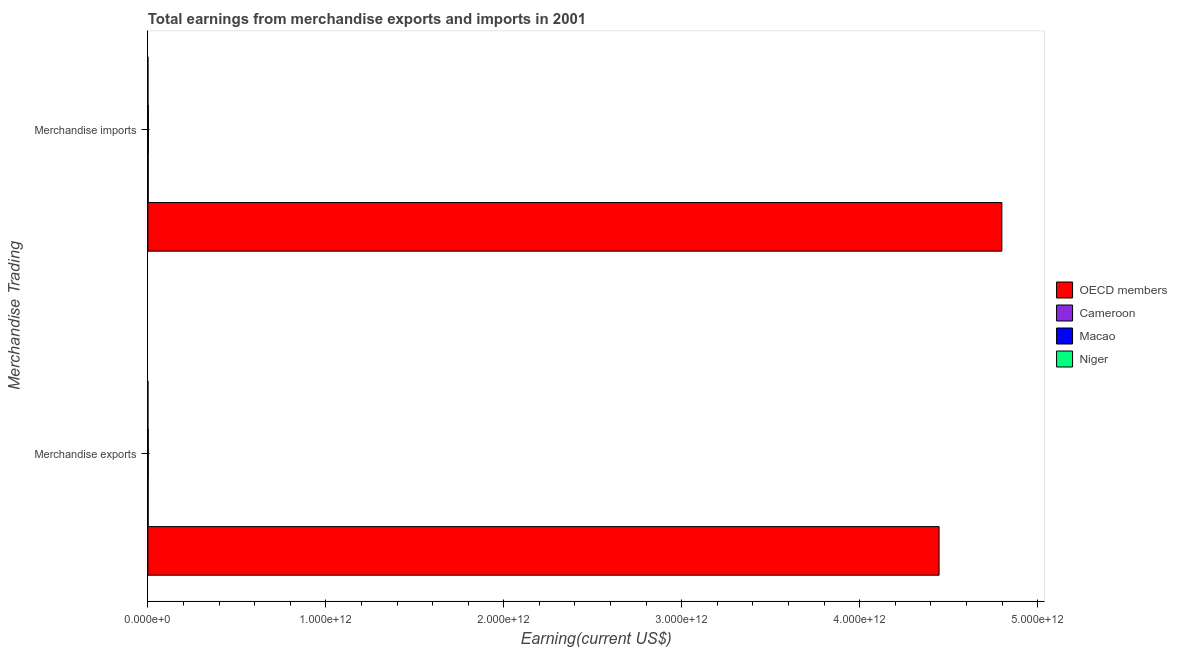How many different coloured bars are there?
Provide a short and direct response. 4. Are the number of bars per tick equal to the number of legend labels?
Ensure brevity in your answer.  Yes. What is the earnings from merchandise exports in Macao?
Ensure brevity in your answer.  2.30e+09. Across all countries, what is the maximum earnings from merchandise exports?
Provide a succinct answer. 4.45e+12. Across all countries, what is the minimum earnings from merchandise exports?
Offer a terse response. 2.72e+08. In which country was the earnings from merchandise exports maximum?
Ensure brevity in your answer.  OECD members. In which country was the earnings from merchandise exports minimum?
Give a very brief answer. Niger. What is the total earnings from merchandise exports in the graph?
Provide a succinct answer. 4.45e+12. What is the difference between the earnings from merchandise imports in Macao and that in Niger?
Your response must be concise. 2.41e+09. What is the difference between the earnings from merchandise imports in Macao and the earnings from merchandise exports in Cameroon?
Your answer should be compact. 1.07e+09. What is the average earnings from merchandise exports per country?
Keep it short and to the point. 1.11e+12. What is the difference between the earnings from merchandise exports and earnings from merchandise imports in Cameroon?
Provide a succinct answer. -1.03e+08. What is the ratio of the earnings from merchandise imports in OECD members to that in Niger?
Keep it short and to the point. 1.16e+04. Is the earnings from merchandise imports in OECD members less than that in Macao?
Your answer should be compact. No. In how many countries, is the earnings from merchandise imports greater than the average earnings from merchandise imports taken over all countries?
Provide a short and direct response. 1. What does the 3rd bar from the bottom in Merchandise exports represents?
Your answer should be very brief. Macao. How many countries are there in the graph?
Your answer should be compact. 4. What is the difference between two consecutive major ticks on the X-axis?
Give a very brief answer. 1.00e+12. Where does the legend appear in the graph?
Offer a very short reply. Center right. How are the legend labels stacked?
Your answer should be compact. Vertical. What is the title of the graph?
Provide a succinct answer. Total earnings from merchandise exports and imports in 2001. Does "Low & middle income" appear as one of the legend labels in the graph?
Your answer should be very brief. No. What is the label or title of the X-axis?
Provide a short and direct response. Earning(current US$). What is the label or title of the Y-axis?
Keep it short and to the point. Merchandise Trading. What is the Earning(current US$) in OECD members in Merchandise exports?
Your answer should be very brief. 4.45e+12. What is the Earning(current US$) in Cameroon in Merchandise exports?
Give a very brief answer. 1.75e+09. What is the Earning(current US$) in Macao in Merchandise exports?
Your response must be concise. 2.30e+09. What is the Earning(current US$) of Niger in Merchandise exports?
Keep it short and to the point. 2.72e+08. What is the Earning(current US$) in OECD members in Merchandise imports?
Provide a succinct answer. 4.80e+12. What is the Earning(current US$) in Cameroon in Merchandise imports?
Provide a succinct answer. 1.85e+09. What is the Earning(current US$) of Macao in Merchandise imports?
Your answer should be very brief. 2.82e+09. What is the Earning(current US$) in Niger in Merchandise imports?
Provide a short and direct response. 4.12e+08. Across all Merchandise Trading, what is the maximum Earning(current US$) of OECD members?
Ensure brevity in your answer.  4.80e+12. Across all Merchandise Trading, what is the maximum Earning(current US$) in Cameroon?
Give a very brief answer. 1.85e+09. Across all Merchandise Trading, what is the maximum Earning(current US$) of Macao?
Your answer should be very brief. 2.82e+09. Across all Merchandise Trading, what is the maximum Earning(current US$) of Niger?
Provide a short and direct response. 4.12e+08. Across all Merchandise Trading, what is the minimum Earning(current US$) in OECD members?
Give a very brief answer. 4.45e+12. Across all Merchandise Trading, what is the minimum Earning(current US$) in Cameroon?
Ensure brevity in your answer.  1.75e+09. Across all Merchandise Trading, what is the minimum Earning(current US$) in Macao?
Make the answer very short. 2.30e+09. Across all Merchandise Trading, what is the minimum Earning(current US$) in Niger?
Your answer should be very brief. 2.72e+08. What is the total Earning(current US$) of OECD members in the graph?
Make the answer very short. 9.24e+12. What is the total Earning(current US$) in Cameroon in the graph?
Your answer should be compact. 3.60e+09. What is the total Earning(current US$) in Macao in the graph?
Make the answer very short. 5.12e+09. What is the total Earning(current US$) of Niger in the graph?
Provide a succinct answer. 6.84e+08. What is the difference between the Earning(current US$) of OECD members in Merchandise exports and that in Merchandise imports?
Offer a terse response. -3.53e+11. What is the difference between the Earning(current US$) in Cameroon in Merchandise exports and that in Merchandise imports?
Your response must be concise. -1.03e+08. What is the difference between the Earning(current US$) of Macao in Merchandise exports and that in Merchandise imports?
Your answer should be very brief. -5.24e+08. What is the difference between the Earning(current US$) of Niger in Merchandise exports and that in Merchandise imports?
Ensure brevity in your answer.  -1.40e+08. What is the difference between the Earning(current US$) of OECD members in Merchandise exports and the Earning(current US$) of Cameroon in Merchandise imports?
Make the answer very short. 4.44e+12. What is the difference between the Earning(current US$) in OECD members in Merchandise exports and the Earning(current US$) in Macao in Merchandise imports?
Offer a terse response. 4.44e+12. What is the difference between the Earning(current US$) in OECD members in Merchandise exports and the Earning(current US$) in Niger in Merchandise imports?
Your answer should be very brief. 4.45e+12. What is the difference between the Earning(current US$) in Cameroon in Merchandise exports and the Earning(current US$) in Macao in Merchandise imports?
Offer a very short reply. -1.07e+09. What is the difference between the Earning(current US$) of Cameroon in Merchandise exports and the Earning(current US$) of Niger in Merchandise imports?
Give a very brief answer. 1.34e+09. What is the difference between the Earning(current US$) in Macao in Merchandise exports and the Earning(current US$) in Niger in Merchandise imports?
Ensure brevity in your answer.  1.89e+09. What is the average Earning(current US$) of OECD members per Merchandise Trading?
Provide a short and direct response. 4.62e+12. What is the average Earning(current US$) of Cameroon per Merchandise Trading?
Your answer should be very brief. 1.80e+09. What is the average Earning(current US$) of Macao per Merchandise Trading?
Offer a very short reply. 2.56e+09. What is the average Earning(current US$) of Niger per Merchandise Trading?
Give a very brief answer. 3.42e+08. What is the difference between the Earning(current US$) of OECD members and Earning(current US$) of Cameroon in Merchandise exports?
Provide a succinct answer. 4.44e+12. What is the difference between the Earning(current US$) of OECD members and Earning(current US$) of Macao in Merchandise exports?
Ensure brevity in your answer.  4.44e+12. What is the difference between the Earning(current US$) of OECD members and Earning(current US$) of Niger in Merchandise exports?
Provide a short and direct response. 4.45e+12. What is the difference between the Earning(current US$) in Cameroon and Earning(current US$) in Macao in Merchandise exports?
Offer a terse response. -5.51e+08. What is the difference between the Earning(current US$) of Cameroon and Earning(current US$) of Niger in Merchandise exports?
Provide a short and direct response. 1.48e+09. What is the difference between the Earning(current US$) in Macao and Earning(current US$) in Niger in Merchandise exports?
Provide a succinct answer. 2.03e+09. What is the difference between the Earning(current US$) in OECD members and Earning(current US$) in Cameroon in Merchandise imports?
Ensure brevity in your answer.  4.80e+12. What is the difference between the Earning(current US$) in OECD members and Earning(current US$) in Macao in Merchandise imports?
Offer a terse response. 4.80e+12. What is the difference between the Earning(current US$) of OECD members and Earning(current US$) of Niger in Merchandise imports?
Offer a terse response. 4.80e+12. What is the difference between the Earning(current US$) of Cameroon and Earning(current US$) of Macao in Merchandise imports?
Make the answer very short. -9.72e+08. What is the difference between the Earning(current US$) of Cameroon and Earning(current US$) of Niger in Merchandise imports?
Keep it short and to the point. 1.44e+09. What is the difference between the Earning(current US$) of Macao and Earning(current US$) of Niger in Merchandise imports?
Your answer should be compact. 2.41e+09. What is the ratio of the Earning(current US$) in OECD members in Merchandise exports to that in Merchandise imports?
Ensure brevity in your answer.  0.93. What is the ratio of the Earning(current US$) in Cameroon in Merchandise exports to that in Merchandise imports?
Give a very brief answer. 0.94. What is the ratio of the Earning(current US$) of Macao in Merchandise exports to that in Merchandise imports?
Give a very brief answer. 0.81. What is the ratio of the Earning(current US$) in Niger in Merchandise exports to that in Merchandise imports?
Give a very brief answer. 0.66. What is the difference between the highest and the second highest Earning(current US$) in OECD members?
Provide a short and direct response. 3.53e+11. What is the difference between the highest and the second highest Earning(current US$) of Cameroon?
Keep it short and to the point. 1.03e+08. What is the difference between the highest and the second highest Earning(current US$) of Macao?
Keep it short and to the point. 5.24e+08. What is the difference between the highest and the second highest Earning(current US$) of Niger?
Give a very brief answer. 1.40e+08. What is the difference between the highest and the lowest Earning(current US$) of OECD members?
Ensure brevity in your answer.  3.53e+11. What is the difference between the highest and the lowest Earning(current US$) of Cameroon?
Offer a very short reply. 1.03e+08. What is the difference between the highest and the lowest Earning(current US$) of Macao?
Your response must be concise. 5.24e+08. What is the difference between the highest and the lowest Earning(current US$) in Niger?
Make the answer very short. 1.40e+08. 